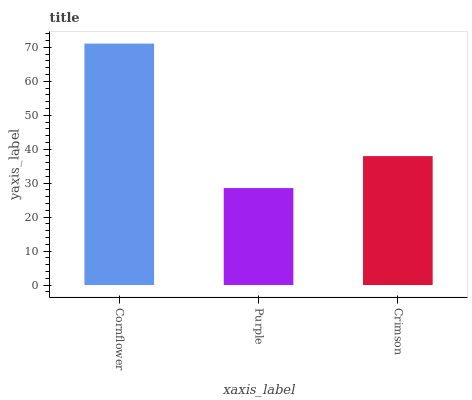Is Purple the minimum?
Answer yes or no. Yes. Is Cornflower the maximum?
Answer yes or no. Yes. Is Crimson the minimum?
Answer yes or no. No. Is Crimson the maximum?
Answer yes or no. No. Is Crimson greater than Purple?
Answer yes or no. Yes. Is Purple less than Crimson?
Answer yes or no. Yes. Is Purple greater than Crimson?
Answer yes or no. No. Is Crimson less than Purple?
Answer yes or no. No. Is Crimson the high median?
Answer yes or no. Yes. Is Crimson the low median?
Answer yes or no. Yes. Is Cornflower the high median?
Answer yes or no. No. Is Cornflower the low median?
Answer yes or no. No. 